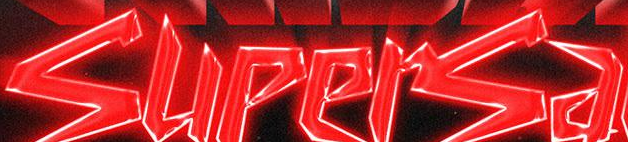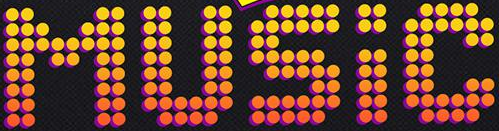What words can you see in these images in sequence, separated by a semicolon? supersa; MUSIC 